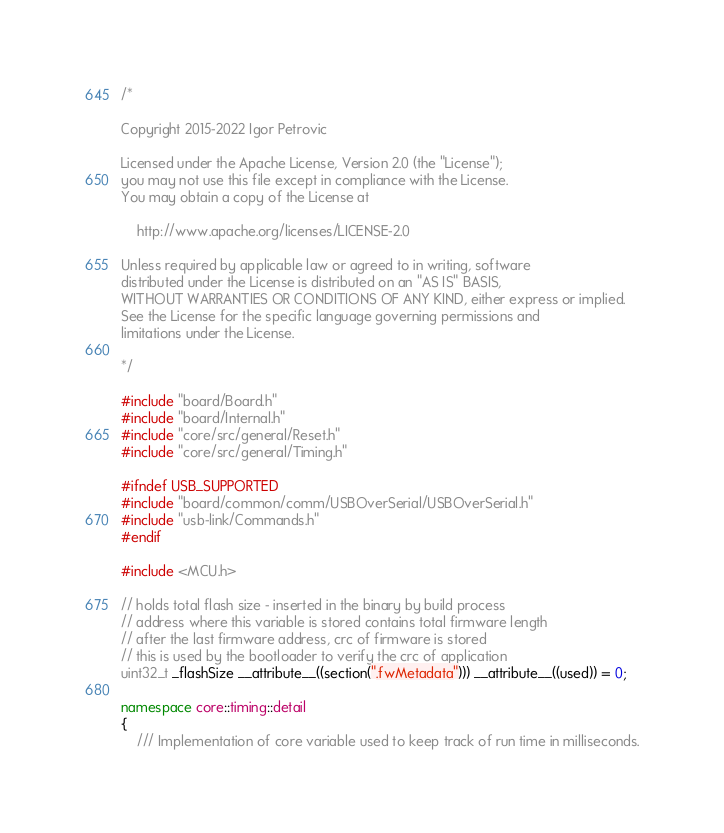<code> <loc_0><loc_0><loc_500><loc_500><_C++_>/*

Copyright 2015-2022 Igor Petrovic

Licensed under the Apache License, Version 2.0 (the "License");
you may not use this file except in compliance with the License.
You may obtain a copy of the License at

    http://www.apache.org/licenses/LICENSE-2.0

Unless required by applicable law or agreed to in writing, software
distributed under the License is distributed on an "AS IS" BASIS,
WITHOUT WARRANTIES OR CONDITIONS OF ANY KIND, either express or implied.
See the License for the specific language governing permissions and
limitations under the License.

*/

#include "board/Board.h"
#include "board/Internal.h"
#include "core/src/general/Reset.h"
#include "core/src/general/Timing.h"

#ifndef USB_SUPPORTED
#include "board/common/comm/USBOverSerial/USBOverSerial.h"
#include "usb-link/Commands.h"
#endif

#include <MCU.h>

// holds total flash size - inserted in the binary by build process
// address where this variable is stored contains total firmware length
// after the last firmware address, crc of firmware is stored
// this is used by the bootloader to verify the crc of application
uint32_t _flashSize __attribute__((section(".fwMetadata"))) __attribute__((used)) = 0;

namespace core::timing::detail
{
    /// Implementation of core variable used to keep track of run time in milliseconds.</code> 